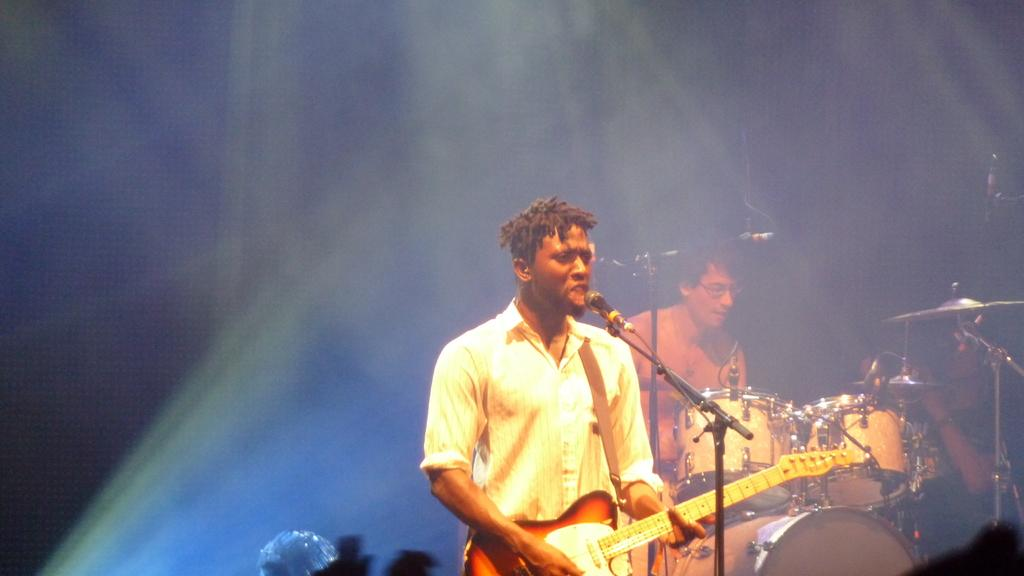What is the man in the image holding? The man is holding a guitar. Can you describe the second person in the image? The second person is sitting and playing drums. What are the two people in the image doing together? They are playing musical instruments, with the man holding a guitar and the second person playing drums. What type of stone is the jellyfish resting on in the image? There is no jellyfish or stone present in the image; it features a man holding a guitar and a person playing drums. 